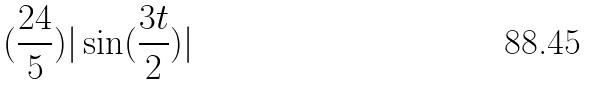<formula> <loc_0><loc_0><loc_500><loc_500>( \frac { 2 4 } { 5 } ) | \sin ( \frac { 3 t } { 2 } ) |</formula> 